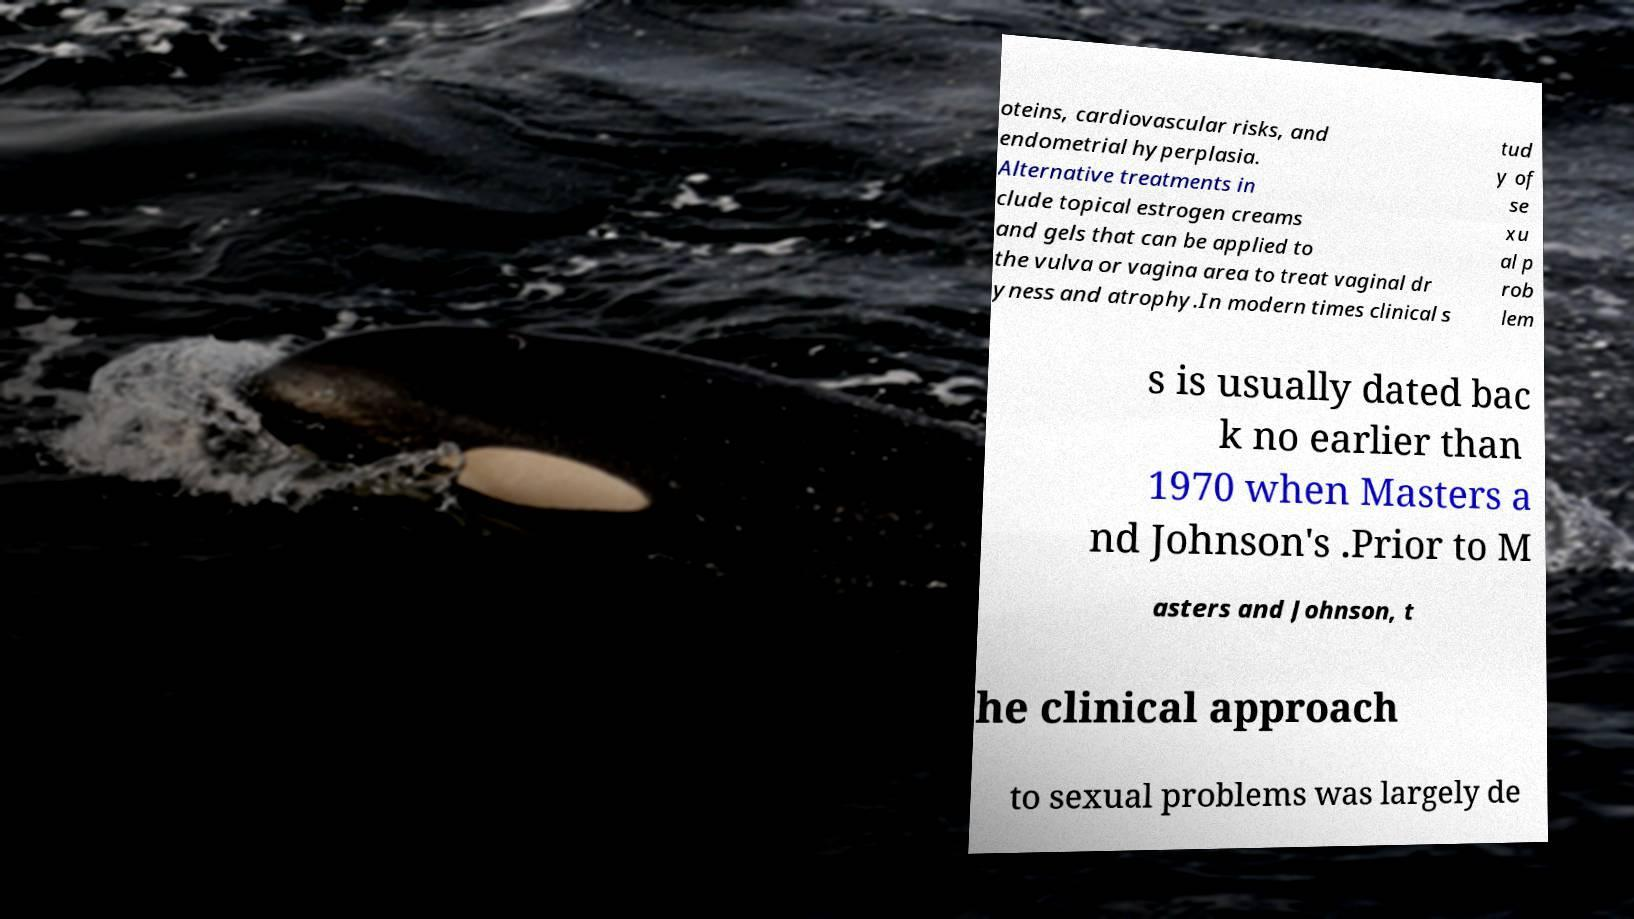I need the written content from this picture converted into text. Can you do that? oteins, cardiovascular risks, and endometrial hyperplasia. Alternative treatments in clude topical estrogen creams and gels that can be applied to the vulva or vagina area to treat vaginal dr yness and atrophy.In modern times clinical s tud y of se xu al p rob lem s is usually dated bac k no earlier than 1970 when Masters a nd Johnson's .Prior to M asters and Johnson, t he clinical approach to sexual problems was largely de 